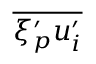<formula> <loc_0><loc_0><loc_500><loc_500>\overline { { \xi _ { p } ^ { \prime } u _ { i } ^ { \prime } } }</formula> 